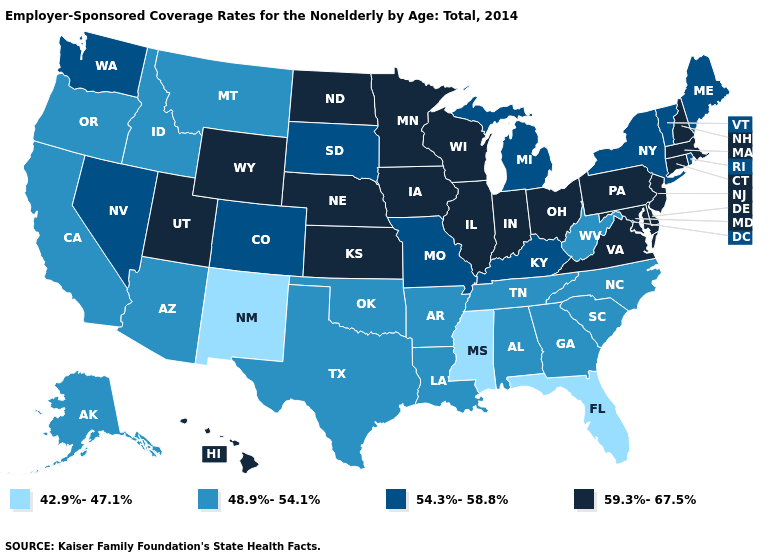Name the states that have a value in the range 59.3%-67.5%?
Give a very brief answer. Connecticut, Delaware, Hawaii, Illinois, Indiana, Iowa, Kansas, Maryland, Massachusetts, Minnesota, Nebraska, New Hampshire, New Jersey, North Dakota, Ohio, Pennsylvania, Utah, Virginia, Wisconsin, Wyoming. What is the value of Arizona?
Keep it brief. 48.9%-54.1%. Which states have the lowest value in the USA?
Give a very brief answer. Florida, Mississippi, New Mexico. Which states have the lowest value in the USA?
Be succinct. Florida, Mississippi, New Mexico. Among the states that border Illinois , does Missouri have the highest value?
Short answer required. No. Which states have the lowest value in the USA?
Concise answer only. Florida, Mississippi, New Mexico. Which states have the lowest value in the South?
Quick response, please. Florida, Mississippi. Among the states that border Arizona , which have the highest value?
Write a very short answer. Utah. Does Florida have the lowest value in the South?
Quick response, please. Yes. What is the value of Illinois?
Give a very brief answer. 59.3%-67.5%. Name the states that have a value in the range 48.9%-54.1%?
Write a very short answer. Alabama, Alaska, Arizona, Arkansas, California, Georgia, Idaho, Louisiana, Montana, North Carolina, Oklahoma, Oregon, South Carolina, Tennessee, Texas, West Virginia. Among the states that border Montana , does Idaho have the lowest value?
Short answer required. Yes. What is the highest value in the USA?
Short answer required. 59.3%-67.5%. Name the states that have a value in the range 42.9%-47.1%?
Concise answer only. Florida, Mississippi, New Mexico. What is the highest value in states that border Idaho?
Quick response, please. 59.3%-67.5%. 